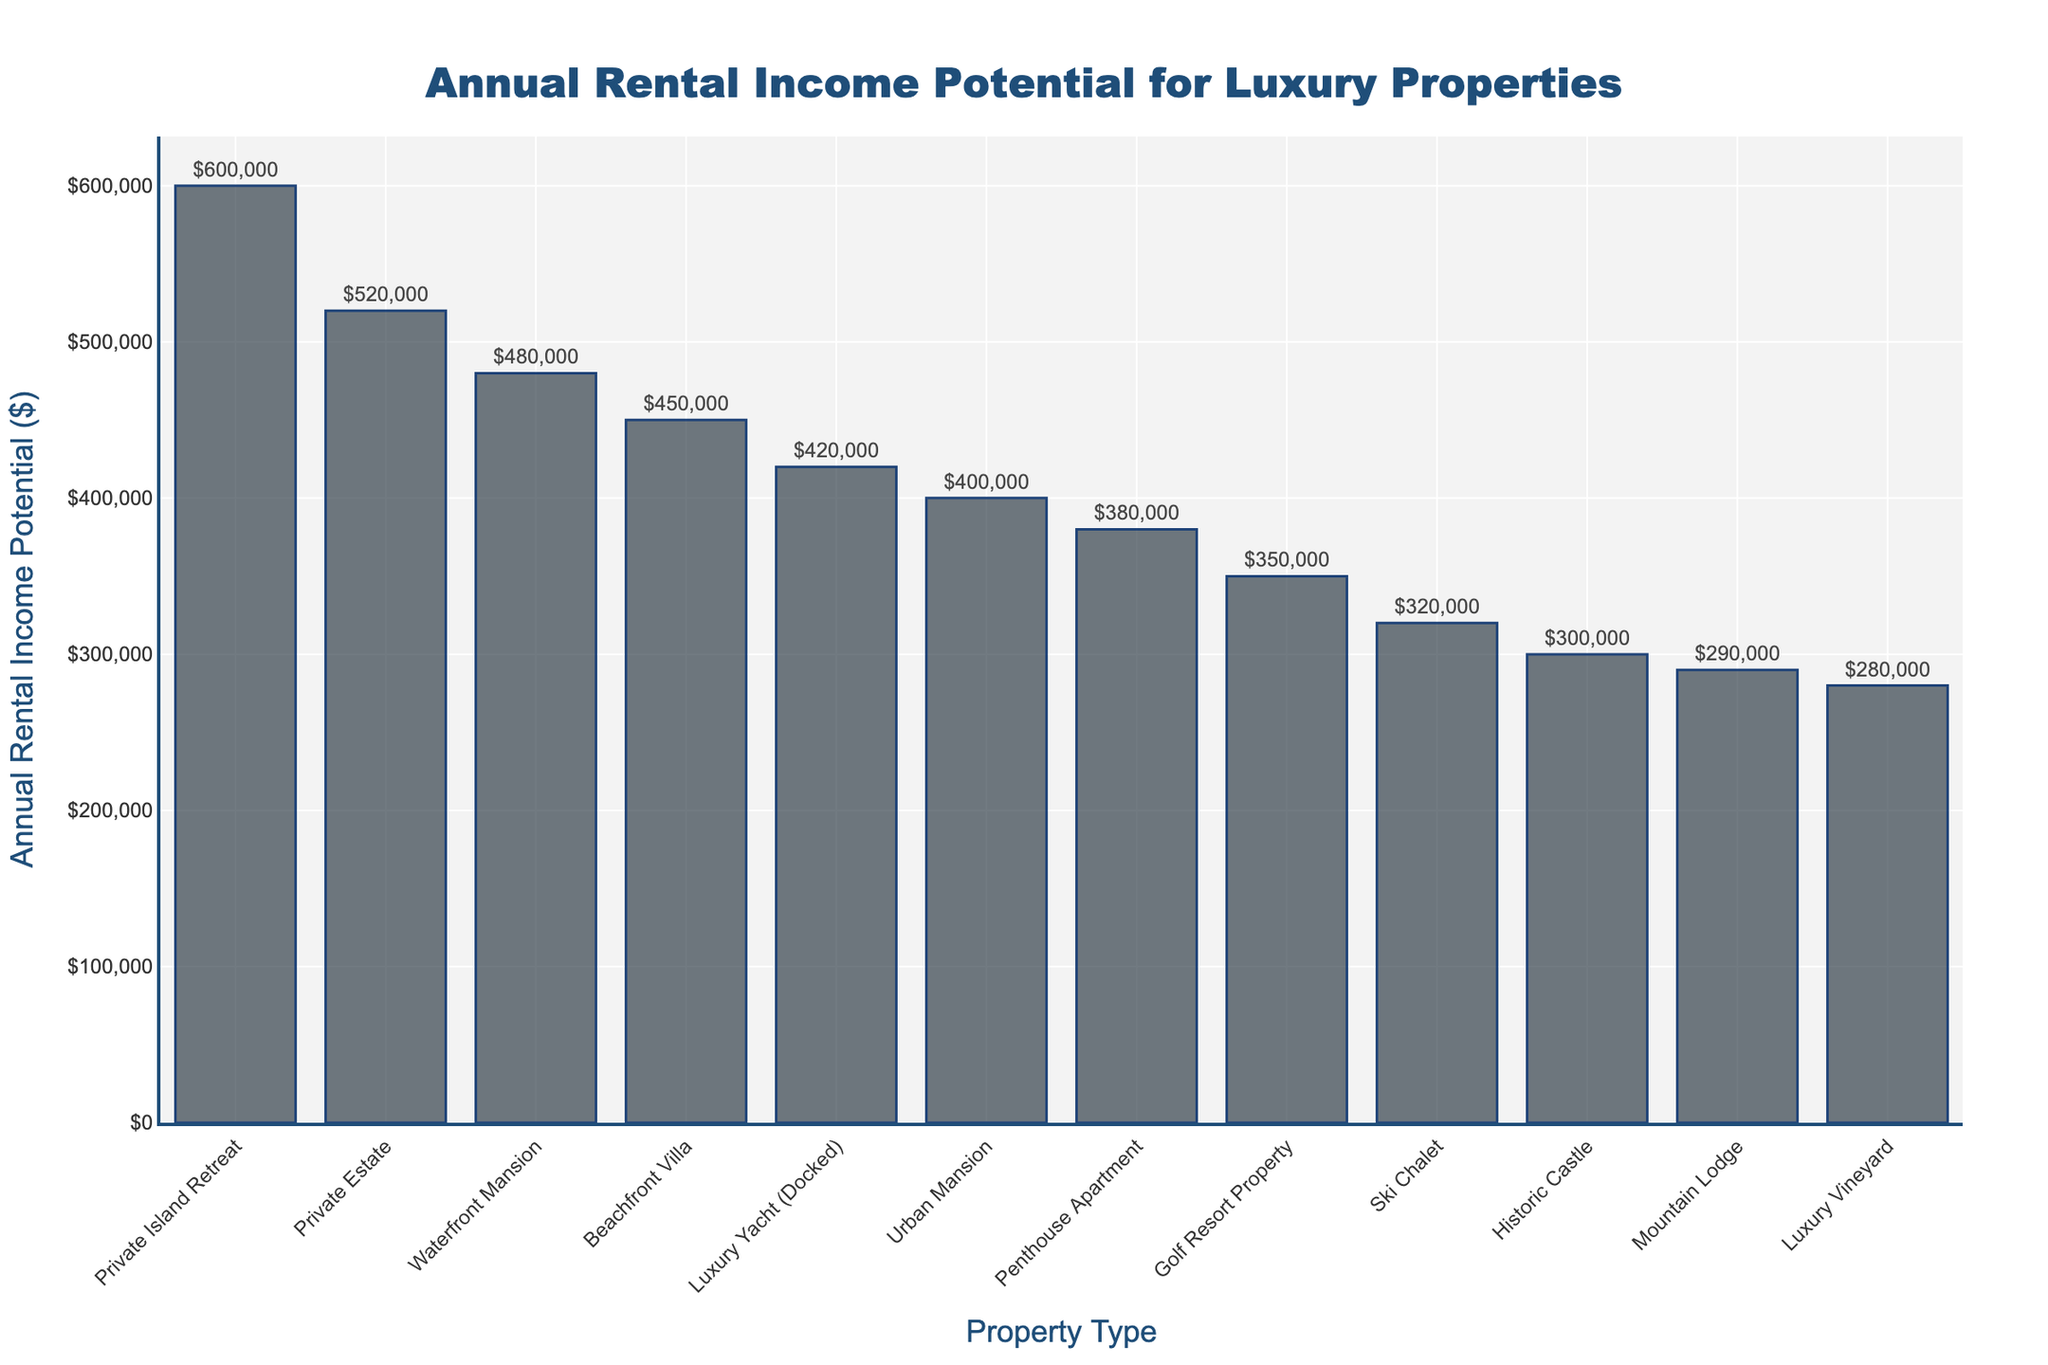Which property type has the highest annual rental income potential? Locate the bar with the highest peak on the plot. The property type corresponding to this bar is Private Island Retreat.
Answer: Private Island Retreat Which property type has the lowest annual rental income potential? Locate the bar with the lowest peak on the plot. The property type corresponding to this bar is Luxury Vineyard.
Answer: Luxury Vineyard What is the combined annual rental income potential of the top three property types? Identify the top three bars by height (Private Island Retreat, Private Estate, and Waterfront Mansion). Sum their values 600000 + 520000 + 480000.
Answer: 1600000 How much more annual rental income potential does a Penthouse Apartment have compared to a Mountain Lodge? Locate the bars for Penthouse Apartment ($380,000) and Mountain Lodge ($290,000). Subtract the smaller value from the larger value (380000 - 290000).
Answer: 90000 Which property type earns more: a Ski Chalet or a Golf Resort Property? Compare the heights of the Ski Chalet bar (320000) and the Golf Resort Property bar (350000). The taller bar corresponds to the Golf Resort Property.
Answer: Golf Resort Property Is the annual rental income potential of a Luxury Yacht (Docked) closer to that of an Urban Mansion or a Waterfront Mansion? Compare the values: Luxury Yacht ($420,000), Urban Mansion ($400,000), and Waterfront Mansion ($480,000). The difference between Luxury Yacht and Urban Mansion is smaller (420000 - 400000 = 20000), compared to difference with Waterfront Mansion (480000 - 420000 = 60000).
Answer: Urban Mansion Which has a higher annual rental income potential: a Historic Castle or a Mountain Lodge? Compare the heights of the bars for Historic Castle ($300,000) and Mountain Lodge ($290,000). The taller bar corresponds to the Historic Castle.
Answer: Historic Castle What is the average annual rental income potential for the properties listed? Sum all the values (450000 + 380000 + 520000 + 320000 + 400000 + 280000 + 350000 + 480000 + 300000 + 600000 + 290000 + 420000 = 4790000). Divide by the number of properties (12).
Answer: 399167 How do the annual rental incomes of an Urban Mansion and a Beachfront Villa compare in terms of color and height? Both bars are colored in the same shade. Beachfront Villa ($450,000) is slightly higher than Urban Mansion ($400,000). The heights and similar colors make them appear closely related visually with slight differences in height.
Answer: Similar color, Beachfront Villa higher What is the difference in annual rental income potential between the highest earning property type and the lowest earning property type? Identify the highest earning (Private Island Retreat, $600,000) and the lowest (Luxury Vineyard, $280,000). Subtract the smaller value from the larger value (600000 - 280000).
Answer: 320000 